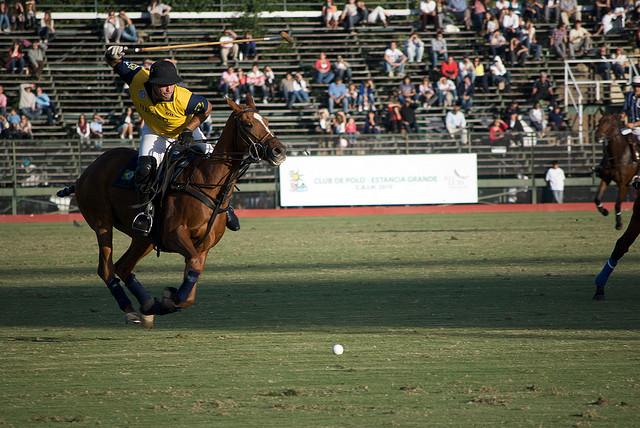What is the color of the man's hat?
Write a very short answer. Black. What color is the shirt of the person holding the rope?
Write a very short answer. Yellow. Is the rider telling the horse to run faster?
Keep it brief. Yes. What is this sport?
Write a very short answer. Polo. What is the man on the horse called?
Be succinct. Jockey. 